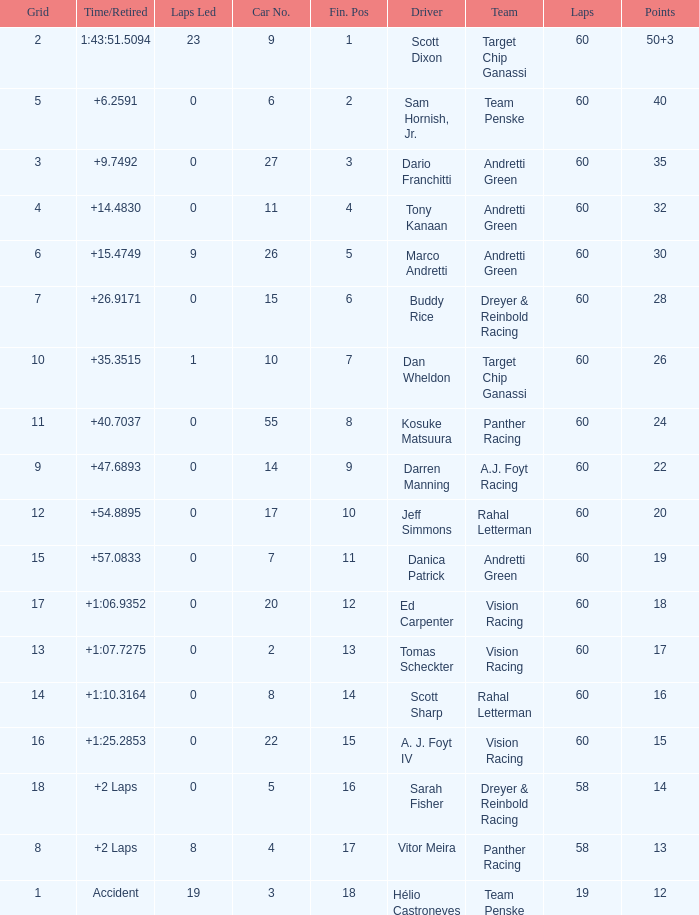Name the total number of grid for 30 1.0. Parse the full table. {'header': ['Grid', 'Time/Retired', 'Laps Led', 'Car No.', 'Fin. Pos', 'Driver', 'Team', 'Laps', 'Points'], 'rows': [['2', '1:43:51.5094', '23', '9', '1', 'Scott Dixon', 'Target Chip Ganassi', '60', '50+3'], ['5', '+6.2591', '0', '6', '2', 'Sam Hornish, Jr.', 'Team Penske', '60', '40'], ['3', '+9.7492', '0', '27', '3', 'Dario Franchitti', 'Andretti Green', '60', '35'], ['4', '+14.4830', '0', '11', '4', 'Tony Kanaan', 'Andretti Green', '60', '32'], ['6', '+15.4749', '9', '26', '5', 'Marco Andretti', 'Andretti Green', '60', '30'], ['7', '+26.9171', '0', '15', '6', 'Buddy Rice', 'Dreyer & Reinbold Racing', '60', '28'], ['10', '+35.3515', '1', '10', '7', 'Dan Wheldon', 'Target Chip Ganassi', '60', '26'], ['11', '+40.7037', '0', '55', '8', 'Kosuke Matsuura', 'Panther Racing', '60', '24'], ['9', '+47.6893', '0', '14', '9', 'Darren Manning', 'A.J. Foyt Racing', '60', '22'], ['12', '+54.8895', '0', '17', '10', 'Jeff Simmons', 'Rahal Letterman', '60', '20'], ['15', '+57.0833', '0', '7', '11', 'Danica Patrick', 'Andretti Green', '60', '19'], ['17', '+1:06.9352', '0', '20', '12', 'Ed Carpenter', 'Vision Racing', '60', '18'], ['13', '+1:07.7275', '0', '2', '13', 'Tomas Scheckter', 'Vision Racing', '60', '17'], ['14', '+1:10.3164', '0', '8', '14', 'Scott Sharp', 'Rahal Letterman', '60', '16'], ['16', '+1:25.2853', '0', '22', '15', 'A. J. Foyt IV', 'Vision Racing', '60', '15'], ['18', '+2 Laps', '0', '5', '16', 'Sarah Fisher', 'Dreyer & Reinbold Racing', '58', '14'], ['8', '+2 Laps', '8', '4', '17', 'Vitor Meira', 'Panther Racing', '58', '13'], ['1', 'Accident', '19', '3', '18', 'Hélio Castroneves', 'Team Penske', '19', '12']]} 